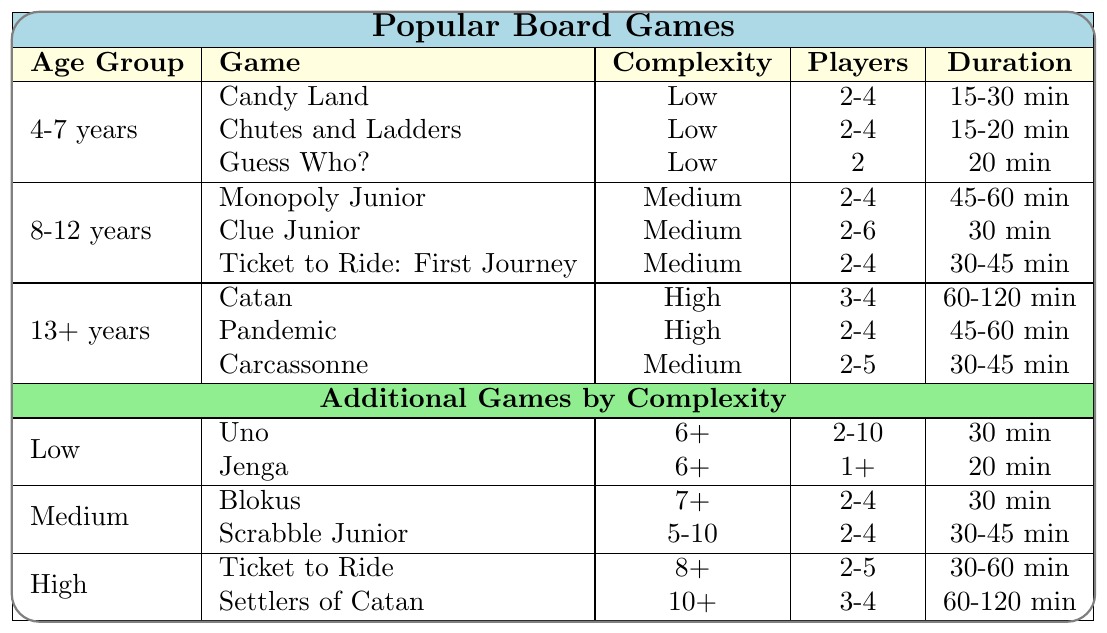What is the complexity level of "Guess Who?" "Guess Who?" is listed under the age group of 4-7 years, and its complexity is categorized as Low according to the table.
Answer: Low How many players can participate in "Clue Junior"? "Clue Junior" is designed for 2 to 6 players, as indicated in the corresponding cell of the table.
Answer: 2-6 players Which game has the longest duration among the 8-12 years age group? In the 8-12 years group, "Monopoly Junior" has the longest duration of 45-60 minutes, which is longer than both "Clue Junior" and "Ticket to Ride: First Journey".
Answer: Monopoly Junior Is "Candy Land" suitable for 7-year-olds? "Candy Land" is specifically listed under the 4-7 years age group, making it suitable for players in that range, which includes 7-year-olds.
Answer: Yes What is the total number of players allowed in all games listed for the age group of 4-7 years? The total number of players for 4-7 years group games is (2-4) for "Candy Land" + (2-4) for "Chutes and Ladders" + 2 for "Guess Who?". The player counts vary, but on average, the total player count can be considered. However, specific maximum counts are 4+4+2=10 when counting the upper limits.
Answer: 10 players Which game has a higher complexity: "Pandemic" or "Carcassonne"? "Pandemic" is categorized as High complexity, whereas "Carcassonne" is categorized as Medium complexity. Therefore, "Pandemic" has a higher complexity level than "Carcassonne".
Answer: Pandemic If a game lasts 60 minutes, which age groups have games that can be played within that duration? Looking at the games that have a maximum duration of 60 minutes— "Catan" (60-120 min) and "Pandemic" (45-60 min) for the 13+ years group and "Monopoly Junior" (45-60 min) for 8-12 years group fit within that duration. Therefore, the age groups that have suitable games are both 8-12 years and 13+ years.
Answer: 8-12 years and 13+ years How many games in total are categorized as Low complexity? There are 3 games in the 4-7 years age group ("Candy Land," "Chutes and Ladders," and "Guess Who?") and 2 additional games ("Uno" and "Jenga") in the Low complexity section, making the total number of Low complexity games 5.
Answer: 5 games 